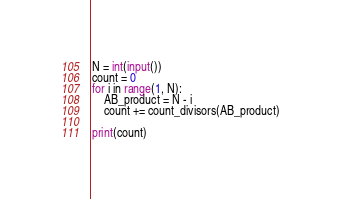Convert code to text. <code><loc_0><loc_0><loc_500><loc_500><_Python_>N = int(input())
count = 0
for i in range(1, N):
    AB_product = N - i
    count += count_divisors(AB_product)

print(count)</code> 